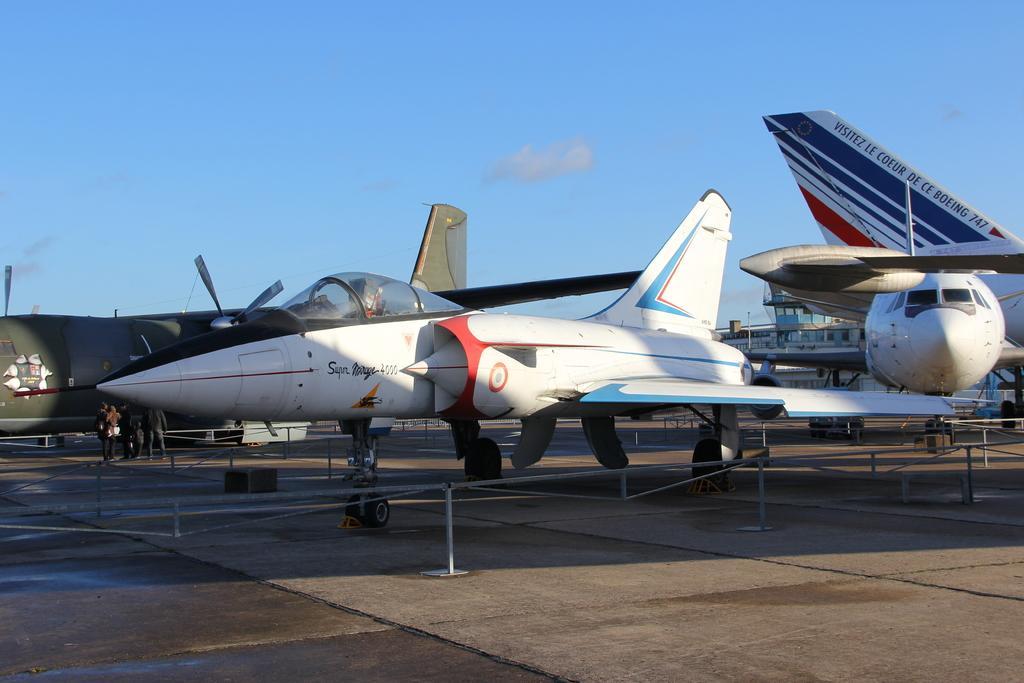In one or two sentences, can you explain what this image depicts? In the picture I can see many airplanes here and here I can see these people are standing on the left side of the image. Here I can see stands. In the background, I can see the building and the blue color of sky. 